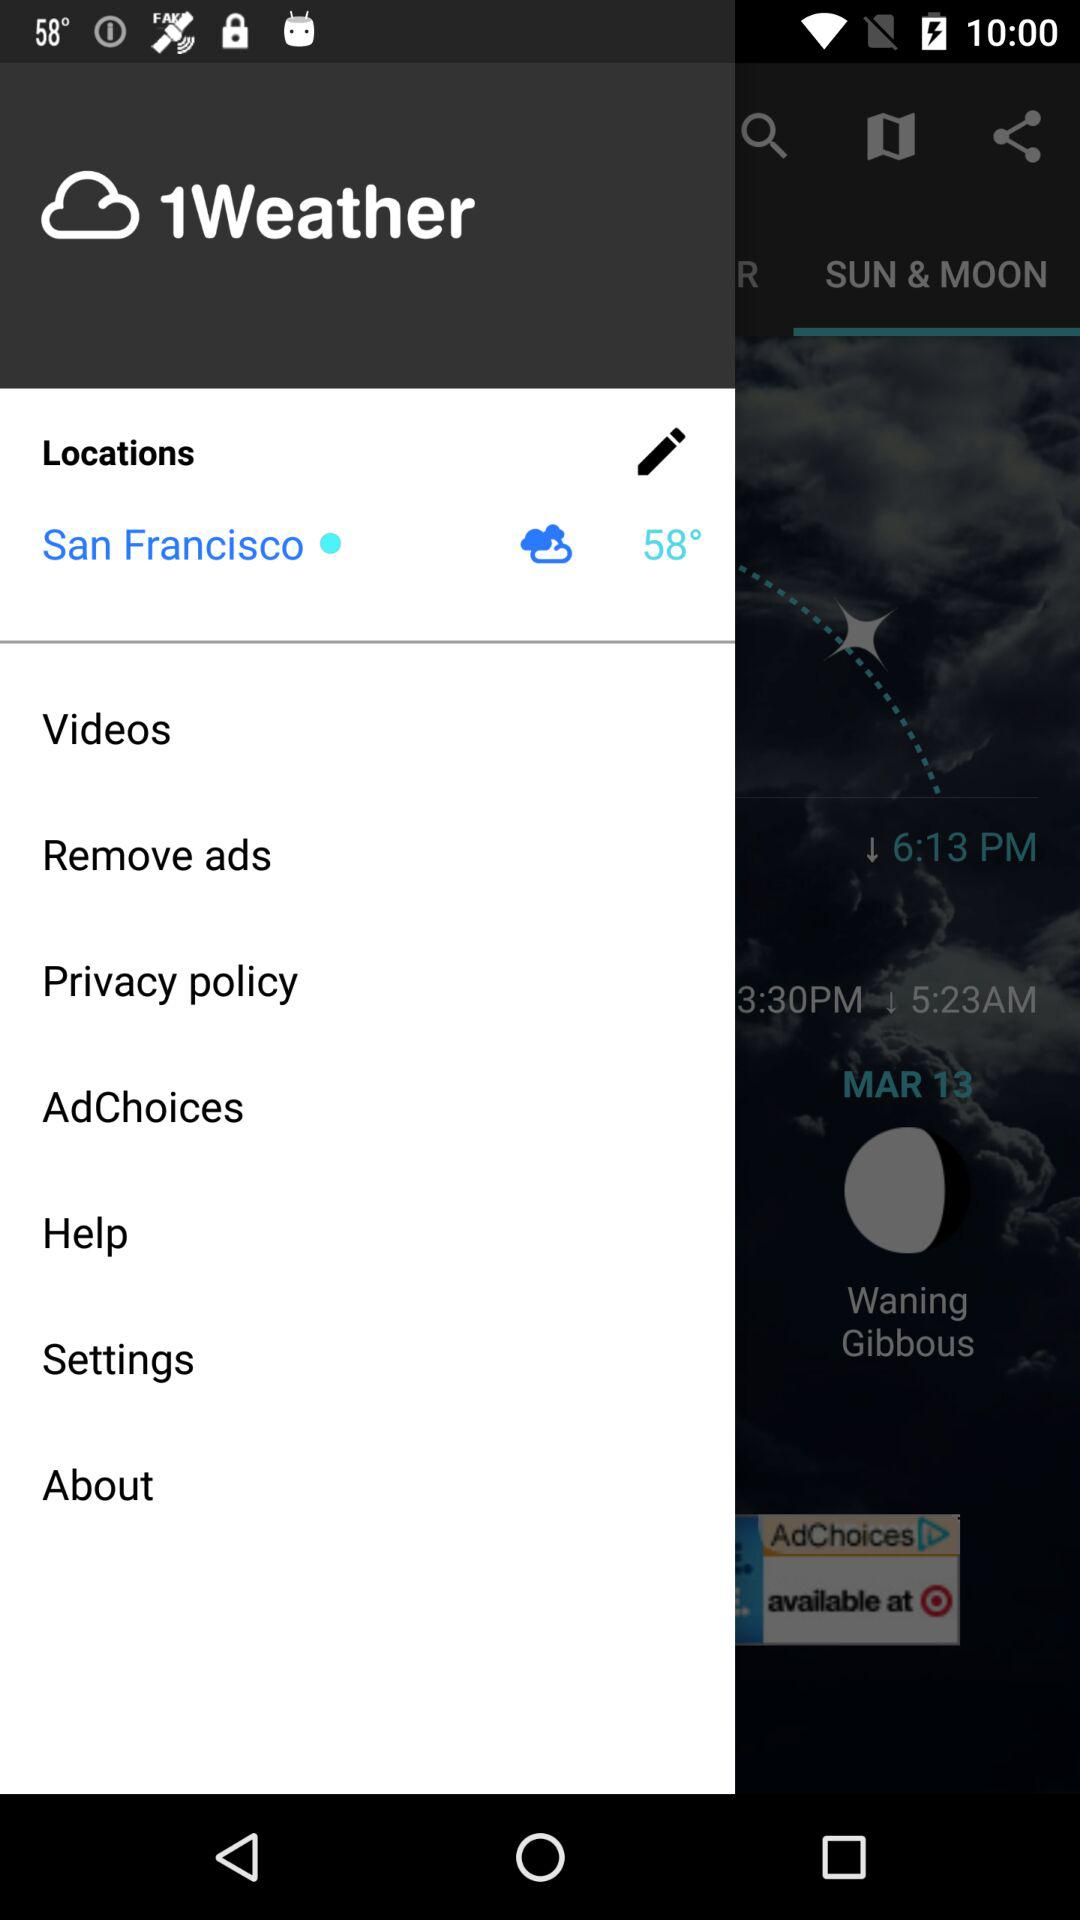What is the name of the application? The name of the application is "1Weather". 